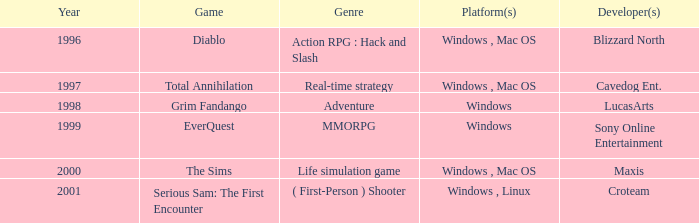What year is the Grim Fandango with a windows platform? 1998.0. 